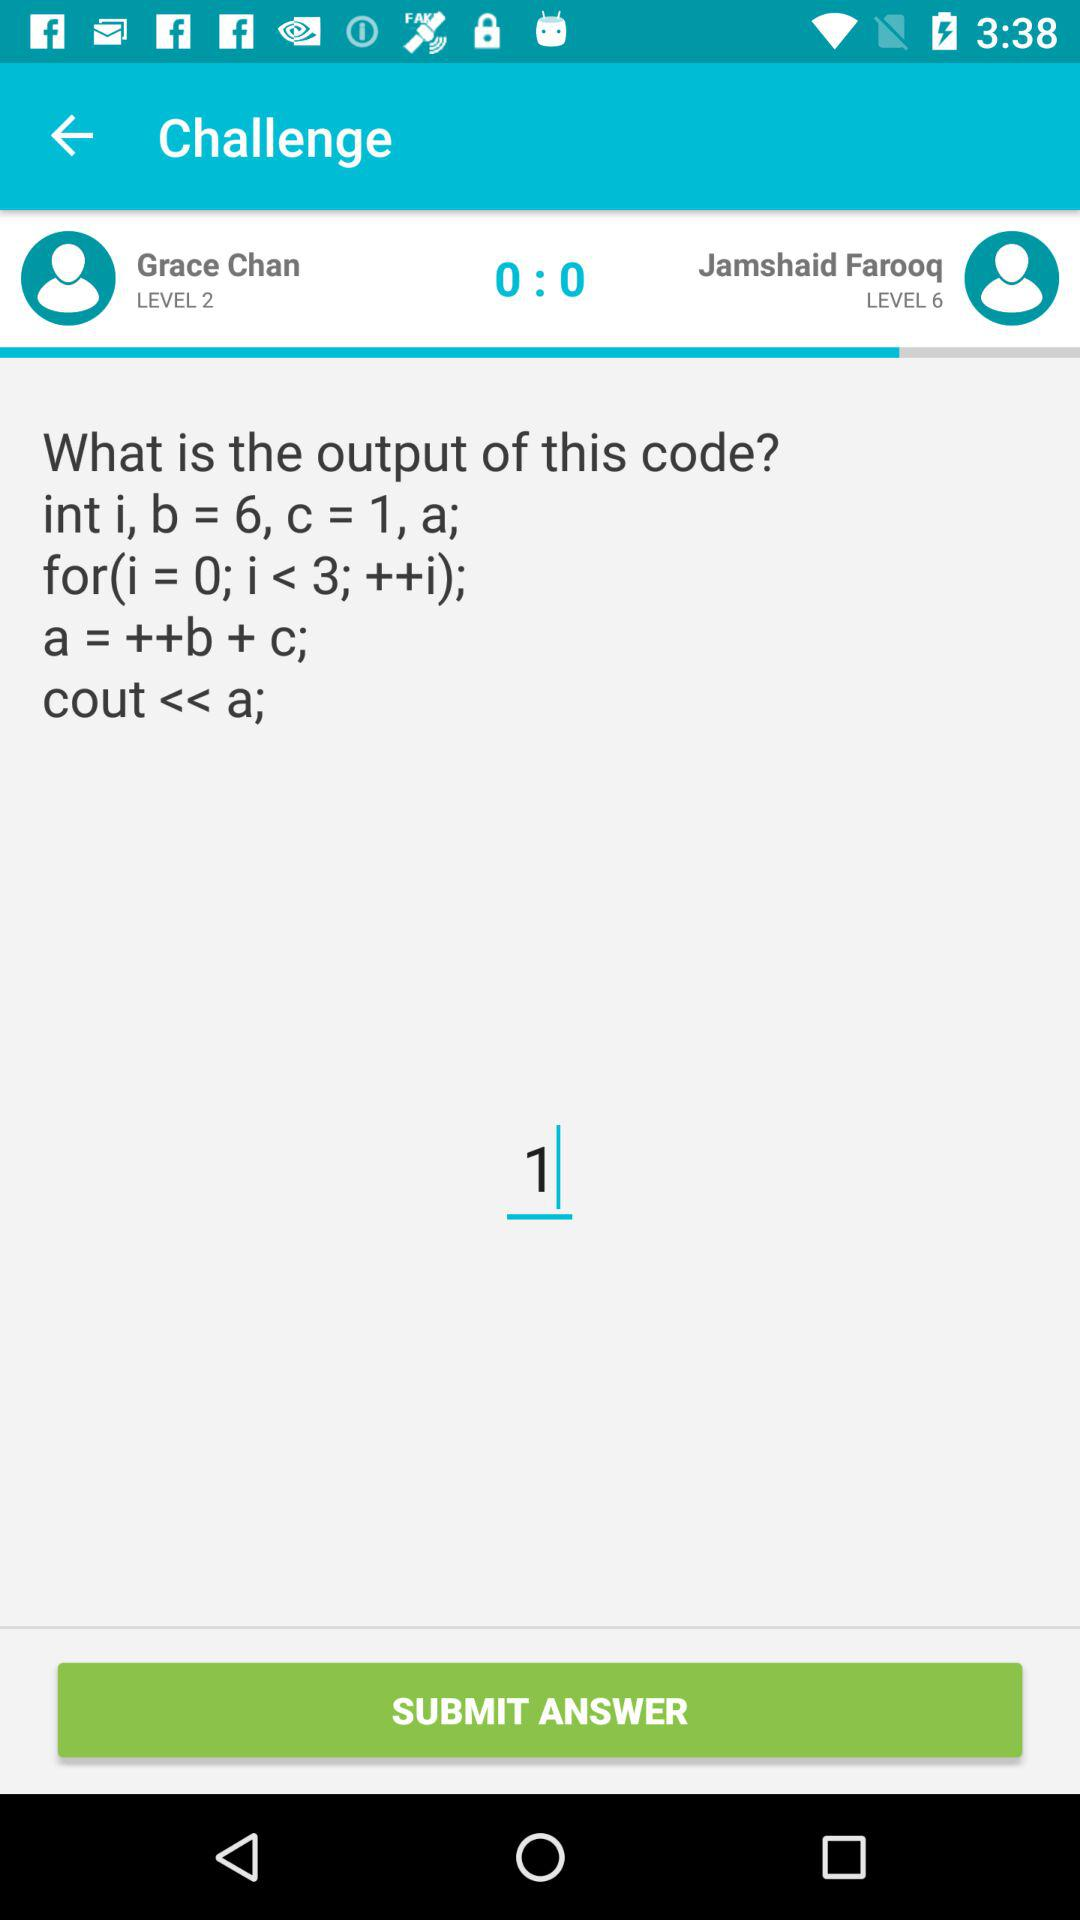Who is on level 2? The person who is on level 2 is Grace Chan. 